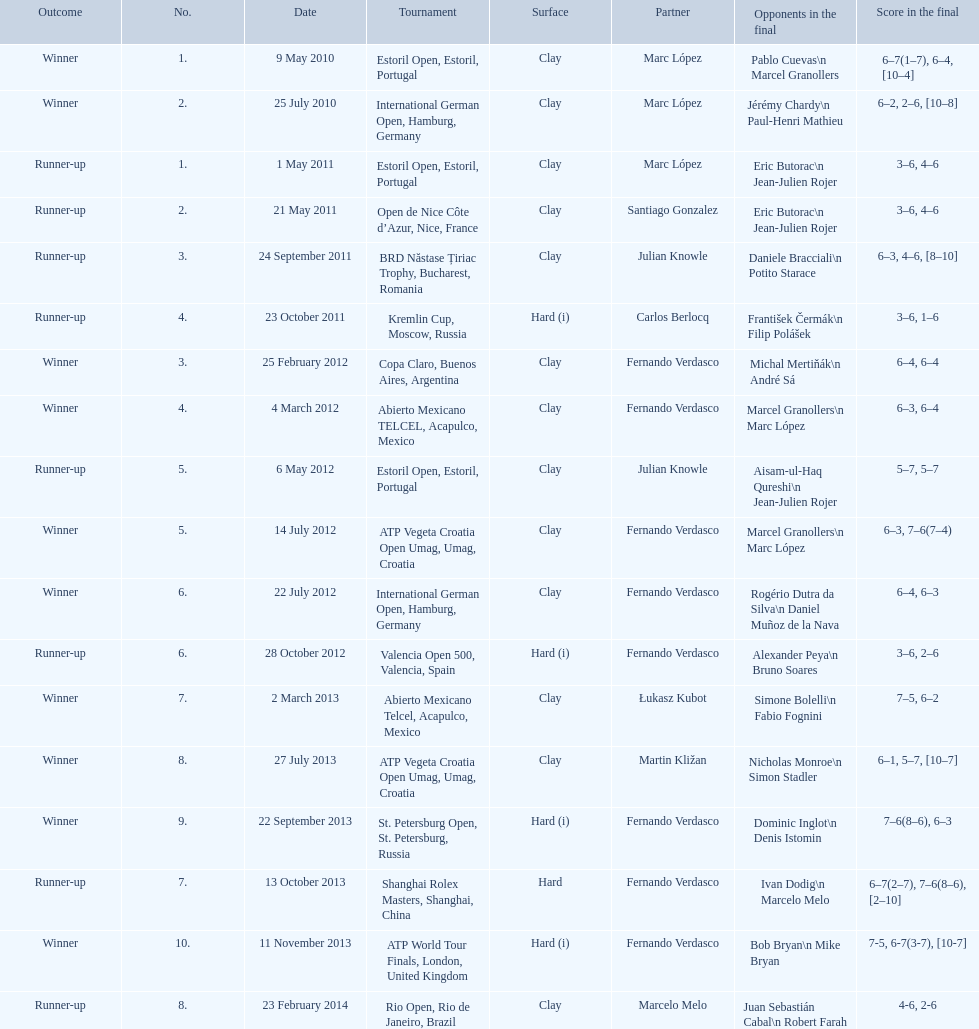How many partners from spain are listed? 2. 